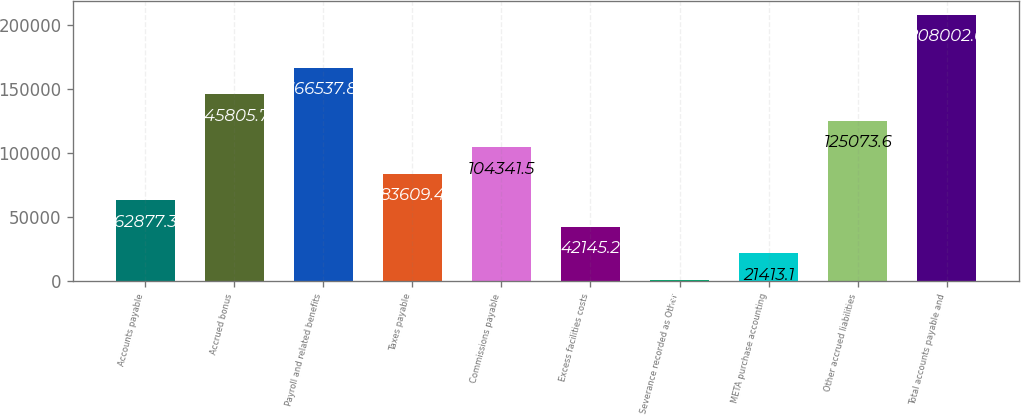Convert chart to OTSL. <chart><loc_0><loc_0><loc_500><loc_500><bar_chart><fcel>Accounts payable<fcel>Accrued bonus<fcel>Payroll and related benefits<fcel>Taxes payable<fcel>Commissions payable<fcel>Excess facilities costs<fcel>Severance recorded as Other<fcel>META purchase accounting<fcel>Other accrued liabilities<fcel>Total accounts payable and<nl><fcel>62877.3<fcel>145806<fcel>166538<fcel>83609.4<fcel>104342<fcel>42145.2<fcel>681<fcel>21413.1<fcel>125074<fcel>208002<nl></chart> 